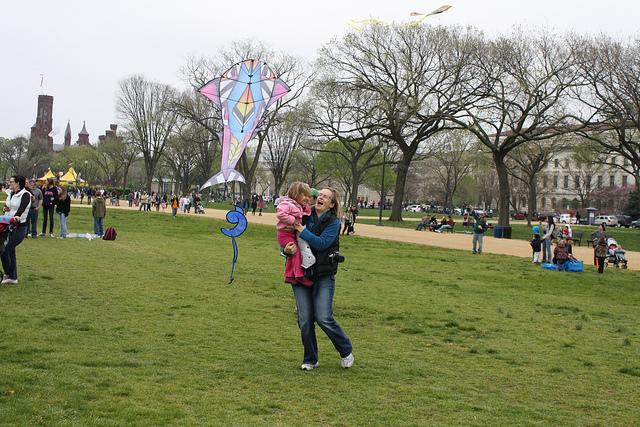What game are the children playing?
Answer briefly. Kite. What number of leaves are in the trees?
Quick response, please. 0. What game is the woman playing?
Be succinct. Kite. Is the woman in blue young?
Answer briefly. No. Are the people wearing sports outfits?
Short answer required. No. How many kites are seen?
Write a very short answer. 2. Does the woman holding the girl in pink look happy?
Be succinct. Yes. What type of footwear is the girl in the left foreground wearing?
Be succinct. Sneakers. Is this a playground?
Answer briefly. No. What color is the girl on left's shoes?
Write a very short answer. White. What is the person in this picture holding?
Concise answer only. Child. What color pants is the woman wearing?
Keep it brief. Blue. What is the girl about to do?
Quick response, please. Fly kite. What color is the kite being held by the woman on the left?
Write a very short answer. Blue. What color is the kite?
Quick response, please. Pink. How many children are wearing pink coats?
Be succinct. 1. Is this area a park?
Give a very brief answer. Yes. How many people are standing?
Short answer required. 20. Is the kite high up in the air?
Answer briefly. No. 